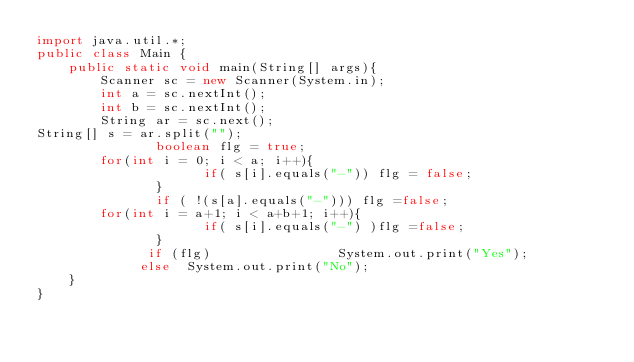<code> <loc_0><loc_0><loc_500><loc_500><_Java_>import java.util.*;
public class Main {
	public static void main(String[] args){
		Scanner sc = new Scanner(System.in);
		int a = sc.nextInt();
		int b = sc.nextInt();
		String ar = sc.next();
String[] s = ar.split("");
               boolean flg = true;
		for(int i = 0; i < a; i++){
                     if( s[i].equals("-")) flg = false;
               }
               if ( !(s[a].equals("-"))) flg =false;
		for(int i = a+1; i < a+b+1; i++){
                     if( s[i].equals("-") )flg =false;
               }
              if (flg)                System.out.print("Yes");
             else  System.out.print("No");
	}
}
</code> 